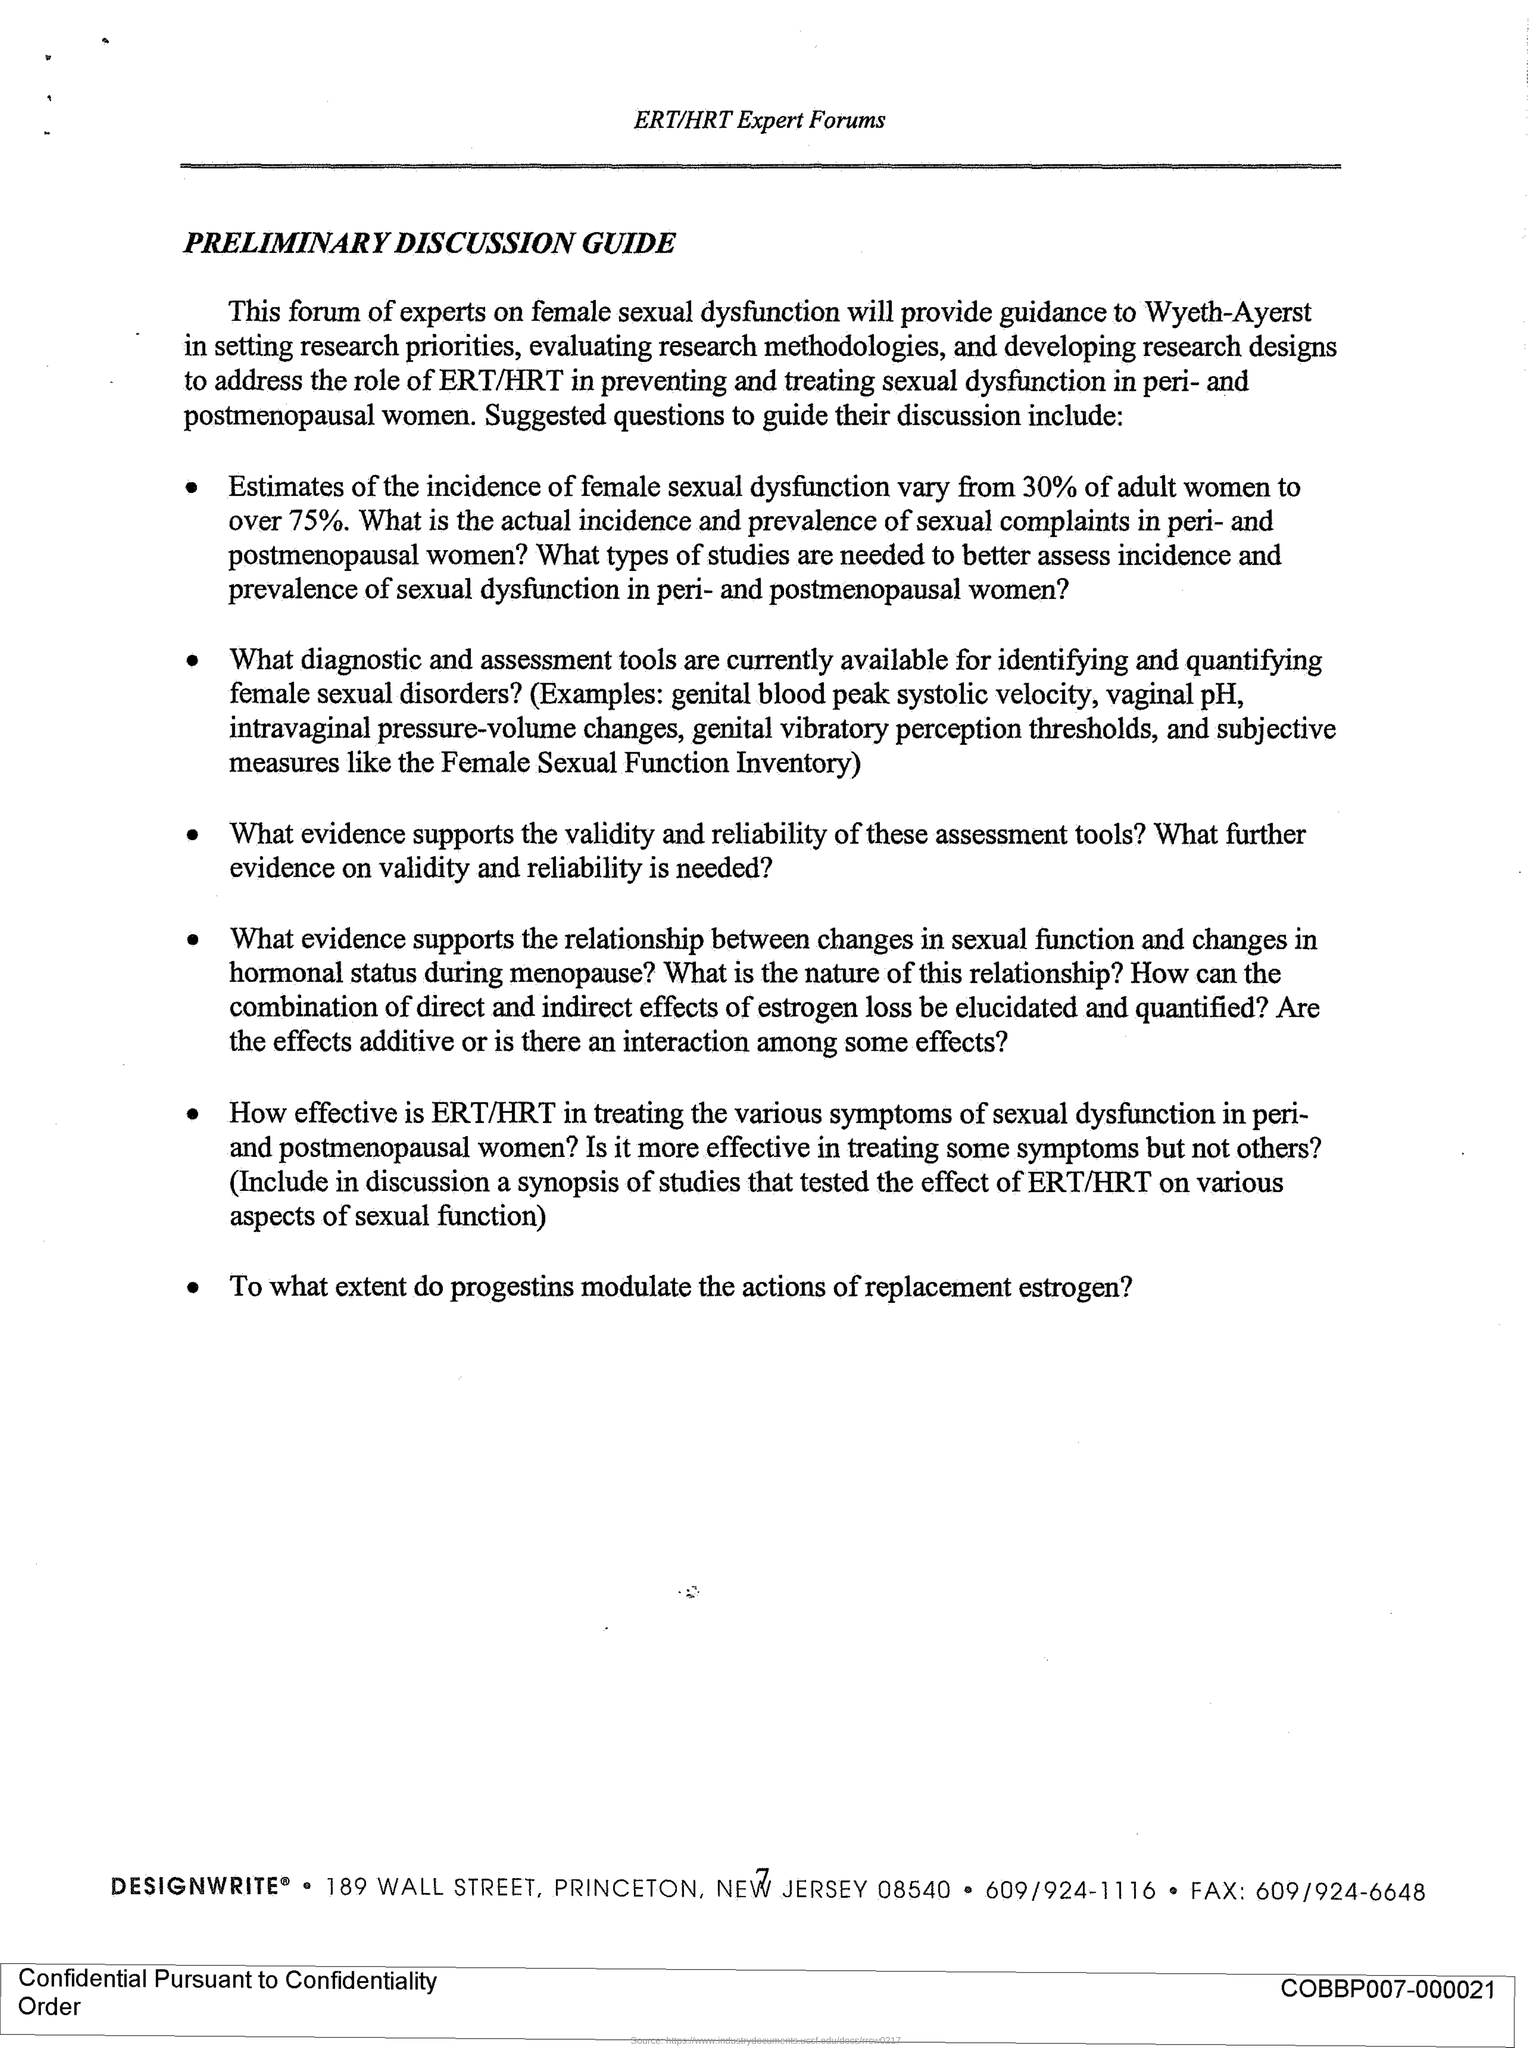What is the page no mentioned in this document?
Your answer should be very brief. 7. Which forum is mentioned in the header of the document?
Provide a short and direct response. ERT/HRT Expert Forums. What is the title of this document?
Provide a short and direct response. Preliminary Discussion Guide. 